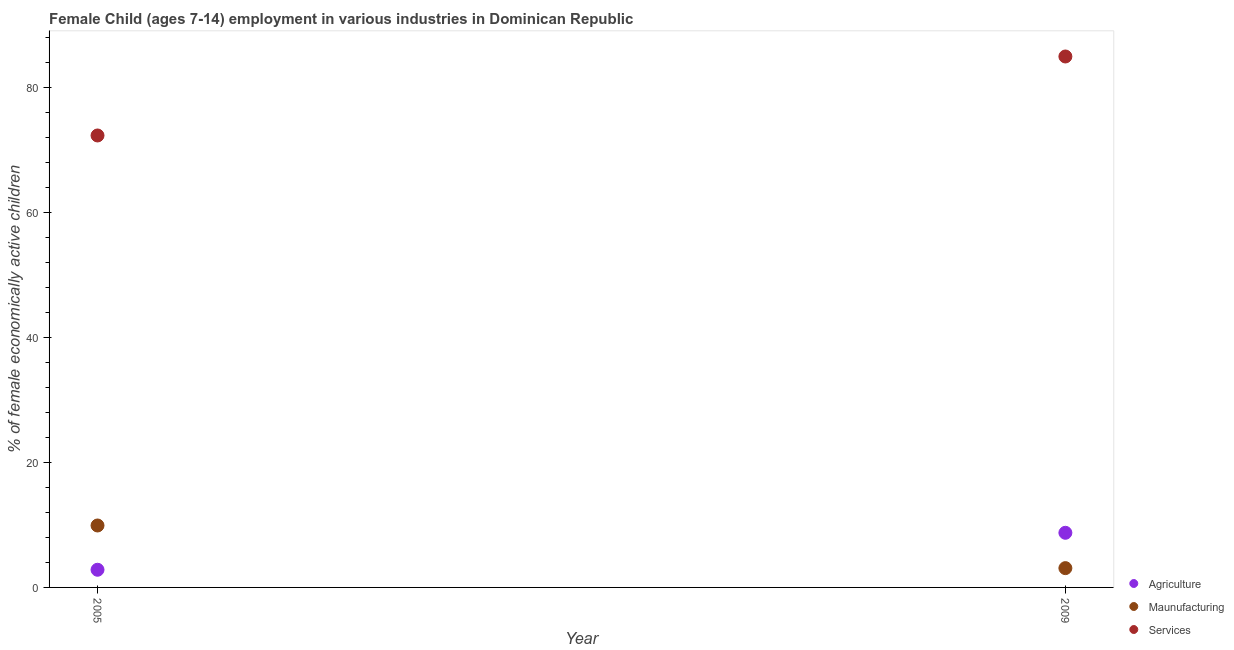Is the number of dotlines equal to the number of legend labels?
Offer a terse response. Yes. What is the percentage of economically active children in manufacturing in 2005?
Keep it short and to the point. 9.92. Across all years, what is the maximum percentage of economically active children in manufacturing?
Provide a succinct answer. 9.92. Across all years, what is the minimum percentage of economically active children in services?
Keep it short and to the point. 72.38. In which year was the percentage of economically active children in manufacturing maximum?
Give a very brief answer. 2005. What is the total percentage of economically active children in manufacturing in the graph?
Offer a very short reply. 13.01. What is the difference between the percentage of economically active children in manufacturing in 2005 and that in 2009?
Make the answer very short. 6.83. What is the difference between the percentage of economically active children in services in 2009 and the percentage of economically active children in manufacturing in 2005?
Make the answer very short. 75.11. What is the average percentage of economically active children in agriculture per year?
Your response must be concise. 5.79. In the year 2009, what is the difference between the percentage of economically active children in services and percentage of economically active children in manufacturing?
Offer a very short reply. 81.94. What is the ratio of the percentage of economically active children in services in 2005 to that in 2009?
Ensure brevity in your answer.  0.85. Is the percentage of economically active children in services in 2005 less than that in 2009?
Your answer should be very brief. Yes. Does the percentage of economically active children in services monotonically increase over the years?
Your answer should be very brief. Yes. Is the percentage of economically active children in services strictly less than the percentage of economically active children in manufacturing over the years?
Offer a terse response. No. Are the values on the major ticks of Y-axis written in scientific E-notation?
Ensure brevity in your answer.  No. Does the graph contain any zero values?
Offer a terse response. No. Does the graph contain grids?
Provide a short and direct response. No. Where does the legend appear in the graph?
Your answer should be very brief. Bottom right. What is the title of the graph?
Offer a very short reply. Female Child (ages 7-14) employment in various industries in Dominican Republic. Does "Spain" appear as one of the legend labels in the graph?
Your answer should be very brief. No. What is the label or title of the X-axis?
Keep it short and to the point. Year. What is the label or title of the Y-axis?
Keep it short and to the point. % of female economically active children. What is the % of female economically active children in Agriculture in 2005?
Ensure brevity in your answer.  2.83. What is the % of female economically active children in Maunufacturing in 2005?
Ensure brevity in your answer.  9.92. What is the % of female economically active children in Services in 2005?
Give a very brief answer. 72.38. What is the % of female economically active children of Agriculture in 2009?
Your response must be concise. 8.75. What is the % of female economically active children in Maunufacturing in 2009?
Keep it short and to the point. 3.09. What is the % of female economically active children of Services in 2009?
Make the answer very short. 85.03. Across all years, what is the maximum % of female economically active children of Agriculture?
Keep it short and to the point. 8.75. Across all years, what is the maximum % of female economically active children of Maunufacturing?
Offer a very short reply. 9.92. Across all years, what is the maximum % of female economically active children in Services?
Provide a succinct answer. 85.03. Across all years, what is the minimum % of female economically active children in Agriculture?
Keep it short and to the point. 2.83. Across all years, what is the minimum % of female economically active children in Maunufacturing?
Make the answer very short. 3.09. Across all years, what is the minimum % of female economically active children in Services?
Make the answer very short. 72.38. What is the total % of female economically active children of Agriculture in the graph?
Your answer should be compact. 11.58. What is the total % of female economically active children in Maunufacturing in the graph?
Your answer should be compact. 13.01. What is the total % of female economically active children in Services in the graph?
Give a very brief answer. 157.41. What is the difference between the % of female economically active children of Agriculture in 2005 and that in 2009?
Your response must be concise. -5.92. What is the difference between the % of female economically active children of Maunufacturing in 2005 and that in 2009?
Provide a succinct answer. 6.83. What is the difference between the % of female economically active children in Services in 2005 and that in 2009?
Your answer should be compact. -12.65. What is the difference between the % of female economically active children of Agriculture in 2005 and the % of female economically active children of Maunufacturing in 2009?
Your response must be concise. -0.26. What is the difference between the % of female economically active children of Agriculture in 2005 and the % of female economically active children of Services in 2009?
Provide a short and direct response. -82.2. What is the difference between the % of female economically active children of Maunufacturing in 2005 and the % of female economically active children of Services in 2009?
Ensure brevity in your answer.  -75.11. What is the average % of female economically active children of Agriculture per year?
Offer a very short reply. 5.79. What is the average % of female economically active children of Maunufacturing per year?
Make the answer very short. 6.5. What is the average % of female economically active children in Services per year?
Offer a very short reply. 78.7. In the year 2005, what is the difference between the % of female economically active children of Agriculture and % of female economically active children of Maunufacturing?
Provide a short and direct response. -7.09. In the year 2005, what is the difference between the % of female economically active children of Agriculture and % of female economically active children of Services?
Your answer should be very brief. -69.55. In the year 2005, what is the difference between the % of female economically active children in Maunufacturing and % of female economically active children in Services?
Give a very brief answer. -62.46. In the year 2009, what is the difference between the % of female economically active children in Agriculture and % of female economically active children in Maunufacturing?
Your answer should be compact. 5.66. In the year 2009, what is the difference between the % of female economically active children in Agriculture and % of female economically active children in Services?
Your response must be concise. -76.28. In the year 2009, what is the difference between the % of female economically active children of Maunufacturing and % of female economically active children of Services?
Keep it short and to the point. -81.94. What is the ratio of the % of female economically active children of Agriculture in 2005 to that in 2009?
Keep it short and to the point. 0.32. What is the ratio of the % of female economically active children in Maunufacturing in 2005 to that in 2009?
Provide a succinct answer. 3.21. What is the ratio of the % of female economically active children in Services in 2005 to that in 2009?
Your answer should be compact. 0.85. What is the difference between the highest and the second highest % of female economically active children of Agriculture?
Offer a very short reply. 5.92. What is the difference between the highest and the second highest % of female economically active children in Maunufacturing?
Make the answer very short. 6.83. What is the difference between the highest and the second highest % of female economically active children of Services?
Offer a very short reply. 12.65. What is the difference between the highest and the lowest % of female economically active children of Agriculture?
Provide a short and direct response. 5.92. What is the difference between the highest and the lowest % of female economically active children of Maunufacturing?
Make the answer very short. 6.83. What is the difference between the highest and the lowest % of female economically active children of Services?
Make the answer very short. 12.65. 